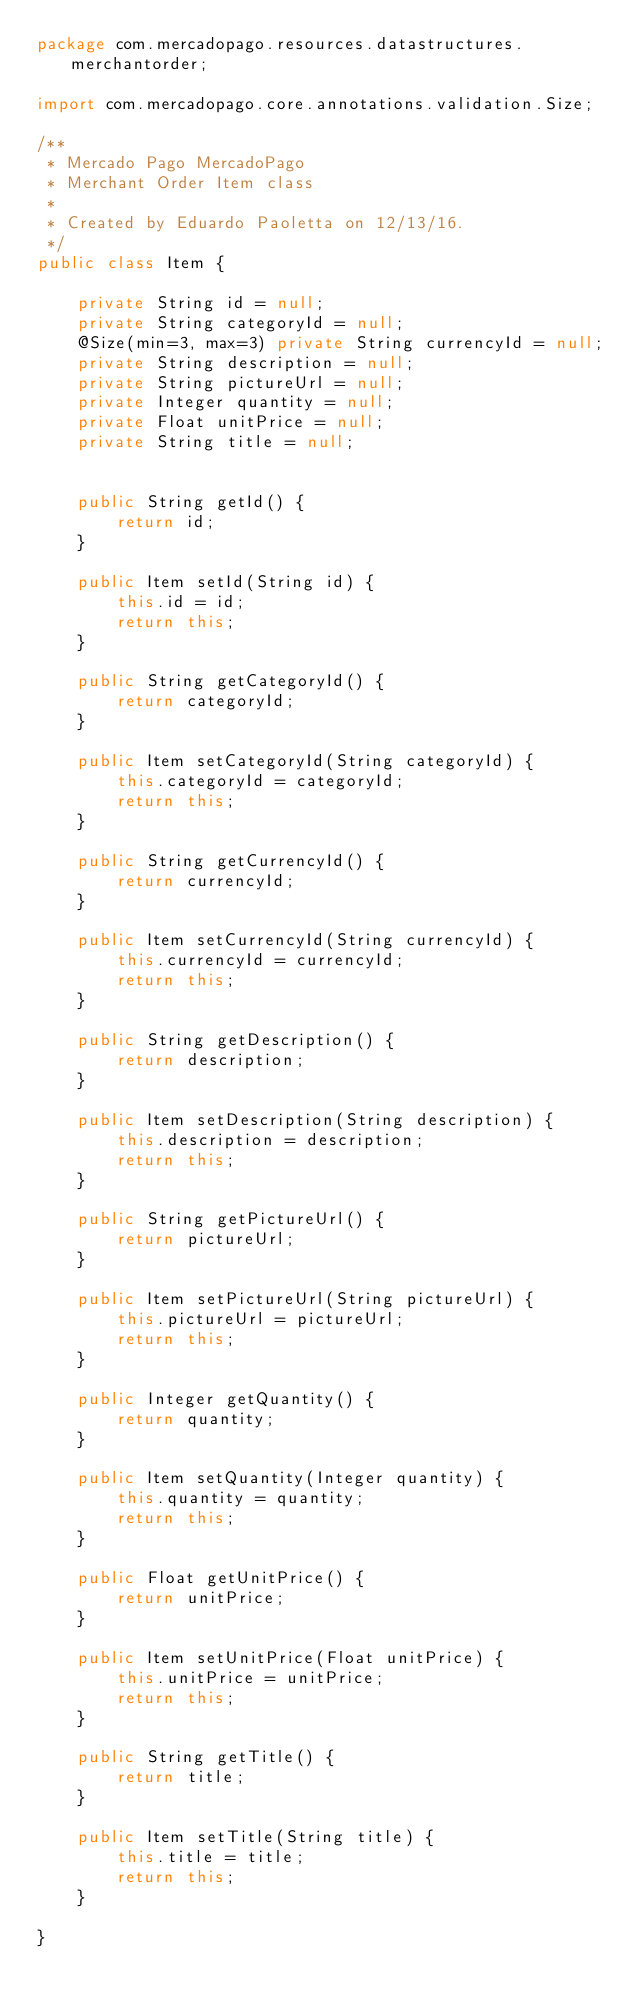<code> <loc_0><loc_0><loc_500><loc_500><_Java_>package com.mercadopago.resources.datastructures.merchantorder;

import com.mercadopago.core.annotations.validation.Size;

/**
 * Mercado Pago MercadoPago
 * Merchant Order Item class
 *
 * Created by Eduardo Paoletta on 12/13/16.
 */
public class Item {

    private String id = null;
    private String categoryId = null;
    @Size(min=3, max=3) private String currencyId = null;
    private String description = null;
    private String pictureUrl = null;
    private Integer quantity = null;
    private Float unitPrice = null;
    private String title = null;


    public String getId() {
        return id;
    }

    public Item setId(String id) {
        this.id = id;
        return this;
    }

    public String getCategoryId() {
        return categoryId;
    }

    public Item setCategoryId(String categoryId) {
        this.categoryId = categoryId;
        return this;
    }

    public String getCurrencyId() {
        return currencyId;
    }

    public Item setCurrencyId(String currencyId) {
        this.currencyId = currencyId;
        return this;
    }

    public String getDescription() {
        return description;
    }

    public Item setDescription(String description) {
        this.description = description;
        return this;
    }

    public String getPictureUrl() {
        return pictureUrl;
    }

    public Item setPictureUrl(String pictureUrl) {
        this.pictureUrl = pictureUrl;
        return this;
    }

    public Integer getQuantity() {
        return quantity;
    }

    public Item setQuantity(Integer quantity) {
        this.quantity = quantity;
        return this;
    }

    public Float getUnitPrice() {
        return unitPrice;
    }

    public Item setUnitPrice(Float unitPrice) {
        this.unitPrice = unitPrice;
        return this;
    }

    public String getTitle() {
        return title;
    }

    public Item setTitle(String title) {
        this.title = title;
        return this;
    }

}
</code> 